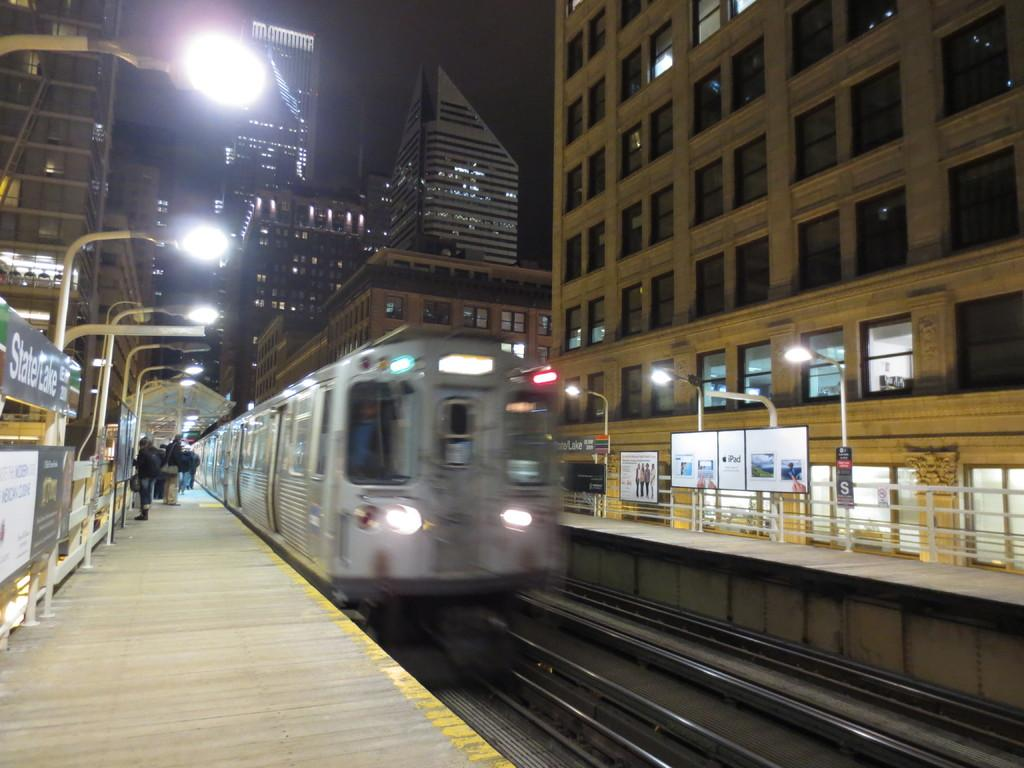What can be seen running parallel to each other in the image? There are two railway tracks in the image. What is present on one of the tracks? There is a train on one of the tracks. Where can people be seen waiting in the image? There is a railway platform on the left side of the image, and there are people standing on it. What structures can be seen in the background of the image? There are buildings visible in the image. Can you tell me the credit score of the person standing on the railway platform? There is no information about the credit score of the person standing on the railway platform in the image. What type of scene is depicted in the image? The image depicts a railway scene, with railway tracks, a train, a railway platform, and people waiting. 